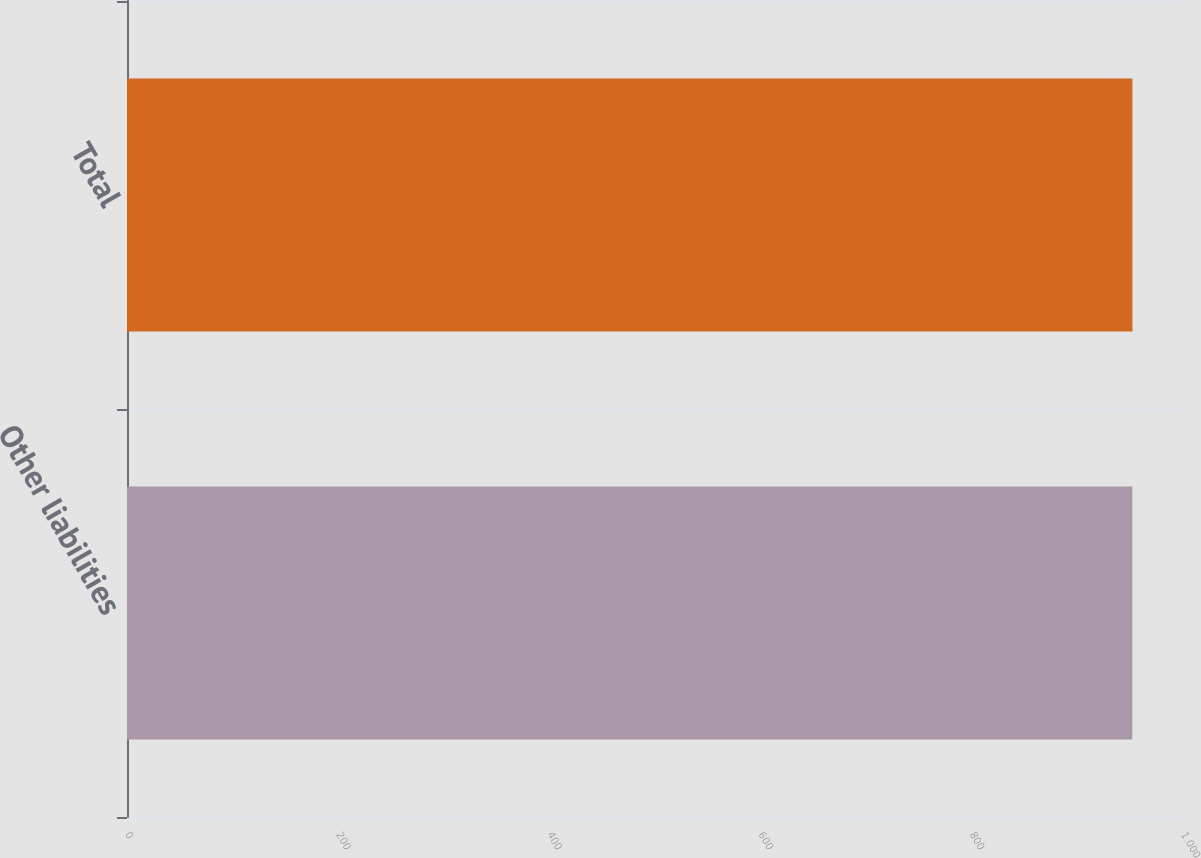Convert chart to OTSL. <chart><loc_0><loc_0><loc_500><loc_500><bar_chart><fcel>Other liabilities<fcel>Total<nl><fcel>952<fcel>952.1<nl></chart> 